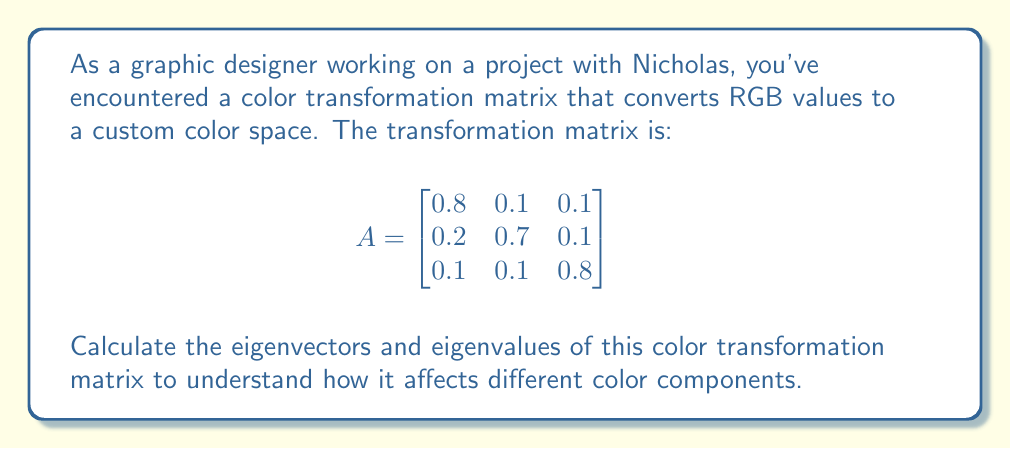Could you help me with this problem? To find the eigenvectors and eigenvalues of matrix A, we follow these steps:

1) First, we need to find the characteristic equation:
   $\det(A - \lambda I) = 0$

2) Expand the determinant:
   $$\begin{vmatrix}
   0.8 - \lambda & 0.1 & 0.1 \\
   0.2 & 0.7 - \lambda & 0.1 \\
   0.1 & 0.1 & 0.8 - \lambda
   \end{vmatrix} = 0$$

3) Calculate the determinant:
   $(0.8 - \lambda)[(0.7 - \lambda)(0.8 - \lambda) - 0.01] - 0.1[0.2(0.8 - \lambda) - 0.1(0.1)] + 0.1[0.2(0.1) - 0.1(0.7 - \lambda)] = 0$

4) Simplify:
   $-\lambda^3 + 2.3\lambda^2 - 1.75\lambda + 0.44 = 0$

5) Solve this cubic equation. The solutions are the eigenvalues:
   $\lambda_1 = 1, \lambda_2 = 0.7, \lambda_3 = 0.6$

6) For each eigenvalue, find the corresponding eigenvector by solving $(A - \lambda I)v = 0$:

   For $\lambda_1 = 1$:
   $$\begin{bmatrix}
   -0.2 & 0.1 & 0.1 \\
   0.2 & -0.3 & 0.1 \\
   0.1 & 0.1 & -0.2
   \end{bmatrix} \begin{bmatrix} v_1 \\ v_2 \\ v_3 \end{bmatrix} = \begin{bmatrix} 0 \\ 0 \\ 0 \end{bmatrix}$$
   Solving this gives $v_1 = \begin{bmatrix} 1 \\ 1 \\ 1 \end{bmatrix}$

   For $\lambda_2 = 0.7$:
   $$\begin{bmatrix}
   0.1 & 0.1 & 0.1 \\
   0.2 & 0 & 0.1 \\
   0.1 & 0.1 & 0.1
   \end{bmatrix} \begin{bmatrix} v_1 \\ v_2 \\ v_3 \end{bmatrix} = \begin{bmatrix} 0 \\ 0 \\ 0 \end{bmatrix}$$
   Solving this gives $v_2 = \begin{bmatrix} -1 \\ 1 \\ 0 \end{bmatrix}$

   For $\lambda_3 = 0.6$:
   $$\begin{bmatrix}
   0.2 & 0.1 & 0.1 \\
   0.2 & 0.1 & 0.1 \\
   0.1 & 0.1 & 0.2
   \end{bmatrix} \begin{bmatrix} v_1 \\ v_2 \\ v_3 \end{bmatrix} = \begin{bmatrix} 0 \\ 0 \\ 0 \end{bmatrix}$$
   Solving this gives $v_3 = \begin{bmatrix} -1 \\ -1 \\ 2 \end{bmatrix}$
Answer: Eigenvalues: $\lambda_1 = 1, \lambda_2 = 0.7, \lambda_3 = 0.6$

Corresponding eigenvectors:
$v_1 = \begin{bmatrix} 1 \\ 1 \\ 1 \end{bmatrix}, v_2 = \begin{bmatrix} -1 \\ 1 \\ 0 \end{bmatrix}, v_3 = \begin{bmatrix} -1 \\ -1 \\ 2 \end{bmatrix}$ 